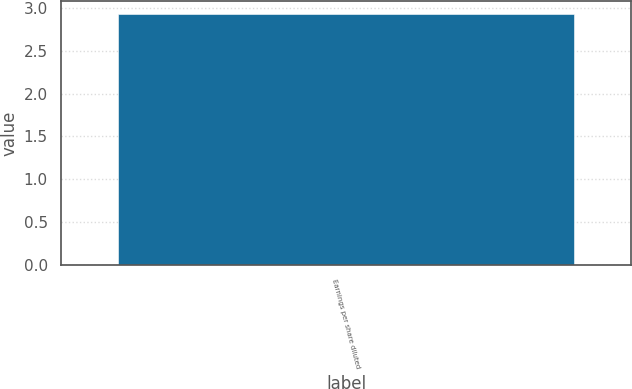<chart> <loc_0><loc_0><loc_500><loc_500><bar_chart><fcel>Earnings per share diluted<nl><fcel>2.93<nl></chart> 